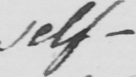Transcribe the text shown in this historical manuscript line. self- 